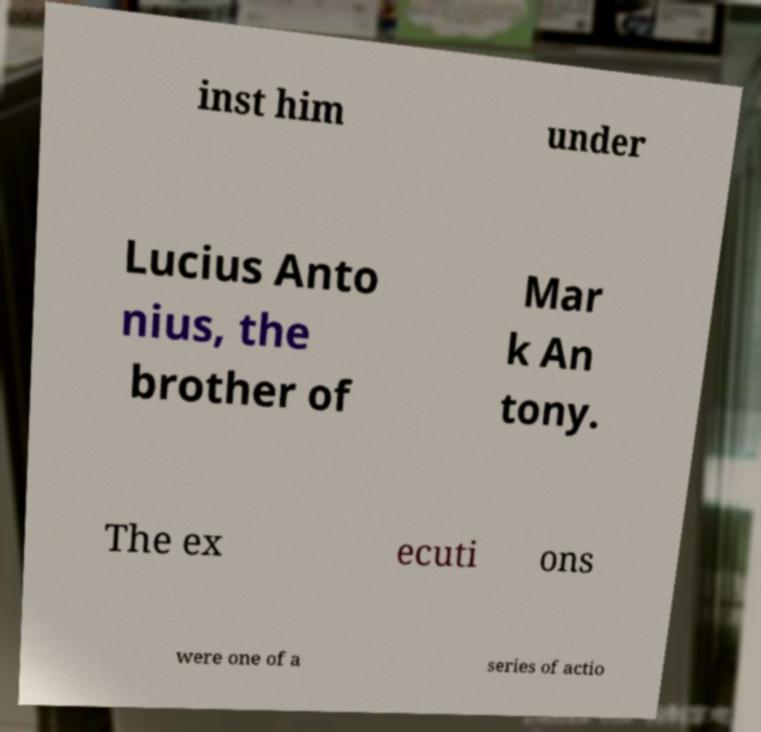There's text embedded in this image that I need extracted. Can you transcribe it verbatim? inst him under Lucius Anto nius, the brother of Mar k An tony. The ex ecuti ons were one of a series of actio 